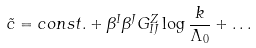Convert formula to latex. <formula><loc_0><loc_0><loc_500><loc_500>\tilde { c } = c o n s t . + \beta ^ { I } \beta ^ { J } G _ { I J } ^ { Z } \log \frac { k } { \Lambda _ { 0 } } + \dots</formula> 